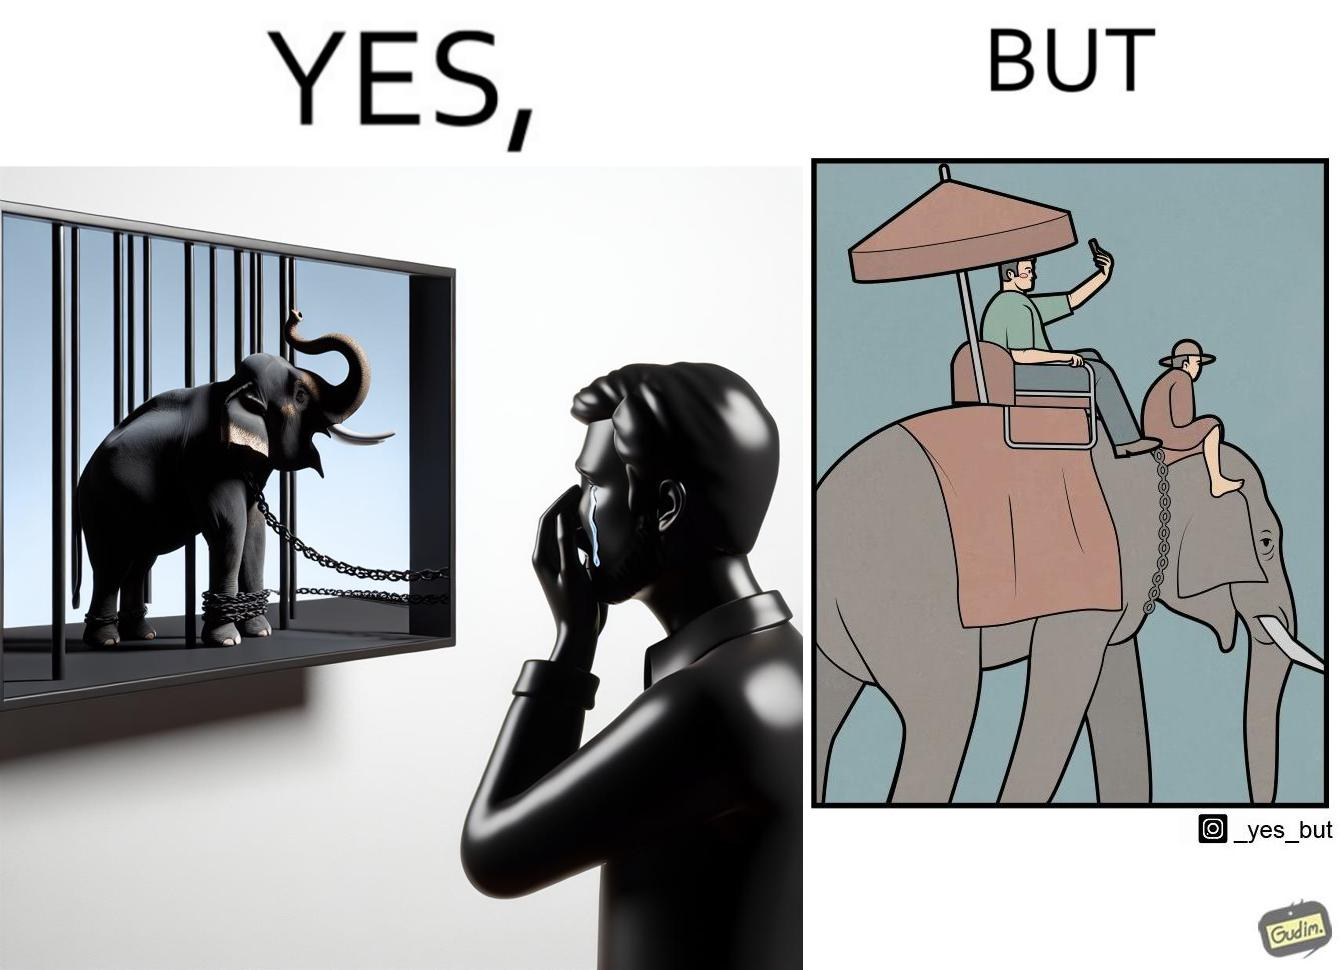Describe the content of this image. The image is ironic, because the people who get sentimental over imprisoned animal while watching TV shows often feel okay when using animals for labor 